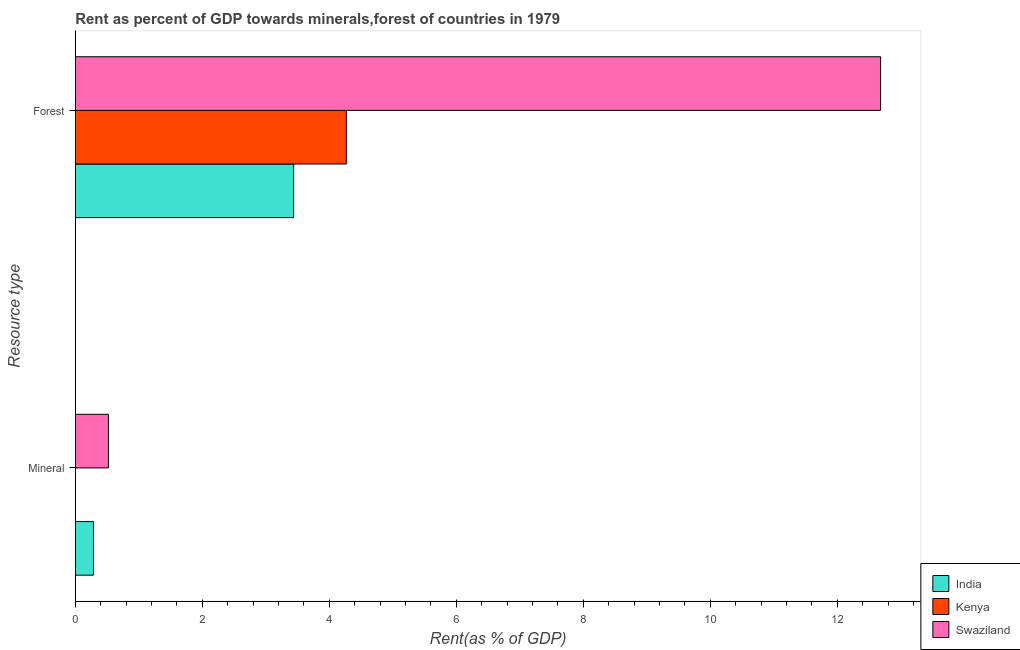How many different coloured bars are there?
Your answer should be very brief. 3. Are the number of bars on each tick of the Y-axis equal?
Your answer should be compact. Yes. How many bars are there on the 2nd tick from the bottom?
Your answer should be compact. 3. What is the label of the 1st group of bars from the top?
Keep it short and to the point. Forest. What is the mineral rent in Swaziland?
Provide a short and direct response. 0.52. Across all countries, what is the maximum mineral rent?
Offer a very short reply. 0.52. Across all countries, what is the minimum mineral rent?
Your answer should be very brief. 0. In which country was the forest rent maximum?
Your response must be concise. Swaziland. In which country was the mineral rent minimum?
Offer a terse response. Kenya. What is the total forest rent in the graph?
Make the answer very short. 20.39. What is the difference between the forest rent in Kenya and that in India?
Make the answer very short. 0.83. What is the difference between the mineral rent in India and the forest rent in Kenya?
Offer a terse response. -3.98. What is the average mineral rent per country?
Your answer should be compact. 0.27. What is the difference between the forest rent and mineral rent in Swaziland?
Keep it short and to the point. 12.16. What is the ratio of the mineral rent in Swaziland to that in Kenya?
Provide a short and direct response. 1789.17. Is the mineral rent in India less than that in Swaziland?
Provide a succinct answer. Yes. What does the 2nd bar from the top in Mineral represents?
Make the answer very short. Kenya. How many bars are there?
Make the answer very short. 6. What is the difference between two consecutive major ticks on the X-axis?
Your answer should be compact. 2. Are the values on the major ticks of X-axis written in scientific E-notation?
Provide a succinct answer. No. Does the graph contain grids?
Offer a terse response. No. How many legend labels are there?
Ensure brevity in your answer.  3. What is the title of the graph?
Provide a short and direct response. Rent as percent of GDP towards minerals,forest of countries in 1979. Does "New Zealand" appear as one of the legend labels in the graph?
Keep it short and to the point. No. What is the label or title of the X-axis?
Offer a very short reply. Rent(as % of GDP). What is the label or title of the Y-axis?
Give a very brief answer. Resource type. What is the Rent(as % of GDP) of India in Mineral?
Provide a short and direct response. 0.29. What is the Rent(as % of GDP) in Kenya in Mineral?
Make the answer very short. 0. What is the Rent(as % of GDP) in Swaziland in Mineral?
Provide a succinct answer. 0.52. What is the Rent(as % of GDP) in India in Forest?
Provide a short and direct response. 3.44. What is the Rent(as % of GDP) in Kenya in Forest?
Give a very brief answer. 4.27. What is the Rent(as % of GDP) in Swaziland in Forest?
Your response must be concise. 12.68. Across all Resource type, what is the maximum Rent(as % of GDP) of India?
Offer a terse response. 3.44. Across all Resource type, what is the maximum Rent(as % of GDP) in Kenya?
Offer a very short reply. 4.27. Across all Resource type, what is the maximum Rent(as % of GDP) of Swaziland?
Keep it short and to the point. 12.68. Across all Resource type, what is the minimum Rent(as % of GDP) in India?
Make the answer very short. 0.29. Across all Resource type, what is the minimum Rent(as % of GDP) in Kenya?
Offer a very short reply. 0. Across all Resource type, what is the minimum Rent(as % of GDP) of Swaziland?
Your answer should be compact. 0.52. What is the total Rent(as % of GDP) of India in the graph?
Provide a succinct answer. 3.72. What is the total Rent(as % of GDP) of Kenya in the graph?
Offer a very short reply. 4.27. What is the total Rent(as % of GDP) in Swaziland in the graph?
Your response must be concise. 13.2. What is the difference between the Rent(as % of GDP) in India in Mineral and that in Forest?
Your answer should be very brief. -3.15. What is the difference between the Rent(as % of GDP) in Kenya in Mineral and that in Forest?
Your response must be concise. -4.27. What is the difference between the Rent(as % of GDP) in Swaziland in Mineral and that in Forest?
Give a very brief answer. -12.16. What is the difference between the Rent(as % of GDP) in India in Mineral and the Rent(as % of GDP) in Kenya in Forest?
Your response must be concise. -3.98. What is the difference between the Rent(as % of GDP) of India in Mineral and the Rent(as % of GDP) of Swaziland in Forest?
Your response must be concise. -12.4. What is the difference between the Rent(as % of GDP) of Kenya in Mineral and the Rent(as % of GDP) of Swaziland in Forest?
Give a very brief answer. -12.68. What is the average Rent(as % of GDP) in India per Resource type?
Offer a terse response. 1.86. What is the average Rent(as % of GDP) in Kenya per Resource type?
Keep it short and to the point. 2.13. What is the average Rent(as % of GDP) of Swaziland per Resource type?
Keep it short and to the point. 6.6. What is the difference between the Rent(as % of GDP) in India and Rent(as % of GDP) in Kenya in Mineral?
Provide a succinct answer. 0.29. What is the difference between the Rent(as % of GDP) of India and Rent(as % of GDP) of Swaziland in Mineral?
Make the answer very short. -0.24. What is the difference between the Rent(as % of GDP) of Kenya and Rent(as % of GDP) of Swaziland in Mineral?
Your answer should be very brief. -0.52. What is the difference between the Rent(as % of GDP) of India and Rent(as % of GDP) of Kenya in Forest?
Your answer should be very brief. -0.83. What is the difference between the Rent(as % of GDP) in India and Rent(as % of GDP) in Swaziland in Forest?
Make the answer very short. -9.24. What is the difference between the Rent(as % of GDP) in Kenya and Rent(as % of GDP) in Swaziland in Forest?
Offer a terse response. -8.41. What is the ratio of the Rent(as % of GDP) of India in Mineral to that in Forest?
Ensure brevity in your answer.  0.08. What is the ratio of the Rent(as % of GDP) of Kenya in Mineral to that in Forest?
Provide a succinct answer. 0. What is the ratio of the Rent(as % of GDP) in Swaziland in Mineral to that in Forest?
Provide a short and direct response. 0.04. What is the difference between the highest and the second highest Rent(as % of GDP) of India?
Ensure brevity in your answer.  3.15. What is the difference between the highest and the second highest Rent(as % of GDP) in Kenya?
Keep it short and to the point. 4.27. What is the difference between the highest and the second highest Rent(as % of GDP) of Swaziland?
Ensure brevity in your answer.  12.16. What is the difference between the highest and the lowest Rent(as % of GDP) in India?
Provide a succinct answer. 3.15. What is the difference between the highest and the lowest Rent(as % of GDP) of Kenya?
Your answer should be very brief. 4.27. What is the difference between the highest and the lowest Rent(as % of GDP) in Swaziland?
Keep it short and to the point. 12.16. 